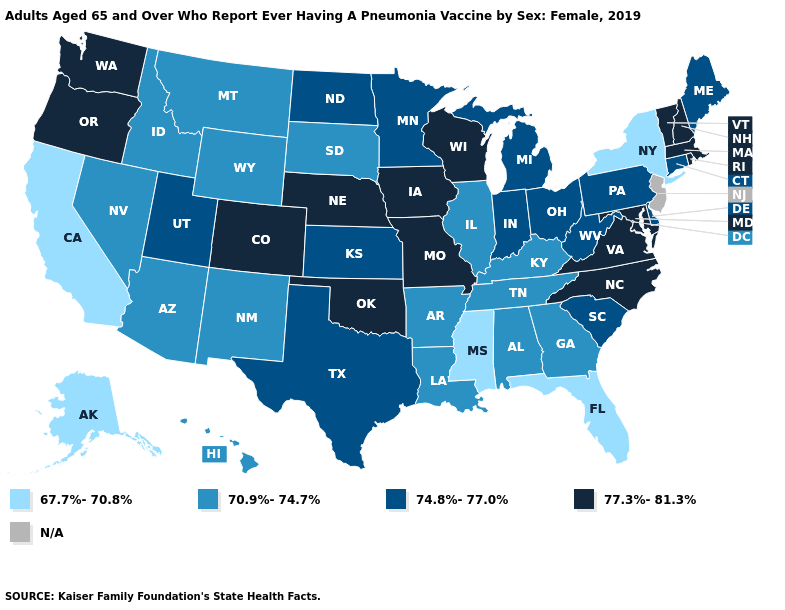Is the legend a continuous bar?
Keep it brief. No. Which states have the lowest value in the MidWest?
Keep it brief. Illinois, South Dakota. Name the states that have a value in the range N/A?
Answer briefly. New Jersey. Does Mississippi have the lowest value in the South?
Keep it brief. Yes. Name the states that have a value in the range 74.8%-77.0%?
Be succinct. Connecticut, Delaware, Indiana, Kansas, Maine, Michigan, Minnesota, North Dakota, Ohio, Pennsylvania, South Carolina, Texas, Utah, West Virginia. Name the states that have a value in the range 67.7%-70.8%?
Answer briefly. Alaska, California, Florida, Mississippi, New York. Name the states that have a value in the range 67.7%-70.8%?
Write a very short answer. Alaska, California, Florida, Mississippi, New York. What is the value of Louisiana?
Write a very short answer. 70.9%-74.7%. Among the states that border Ohio , does Pennsylvania have the lowest value?
Be succinct. No. Which states hav the highest value in the MidWest?
Give a very brief answer. Iowa, Missouri, Nebraska, Wisconsin. Name the states that have a value in the range 70.9%-74.7%?
Concise answer only. Alabama, Arizona, Arkansas, Georgia, Hawaii, Idaho, Illinois, Kentucky, Louisiana, Montana, Nevada, New Mexico, South Dakota, Tennessee, Wyoming. Name the states that have a value in the range 74.8%-77.0%?
Short answer required. Connecticut, Delaware, Indiana, Kansas, Maine, Michigan, Minnesota, North Dakota, Ohio, Pennsylvania, South Carolina, Texas, Utah, West Virginia. Name the states that have a value in the range 70.9%-74.7%?
Quick response, please. Alabama, Arizona, Arkansas, Georgia, Hawaii, Idaho, Illinois, Kentucky, Louisiana, Montana, Nevada, New Mexico, South Dakota, Tennessee, Wyoming. 